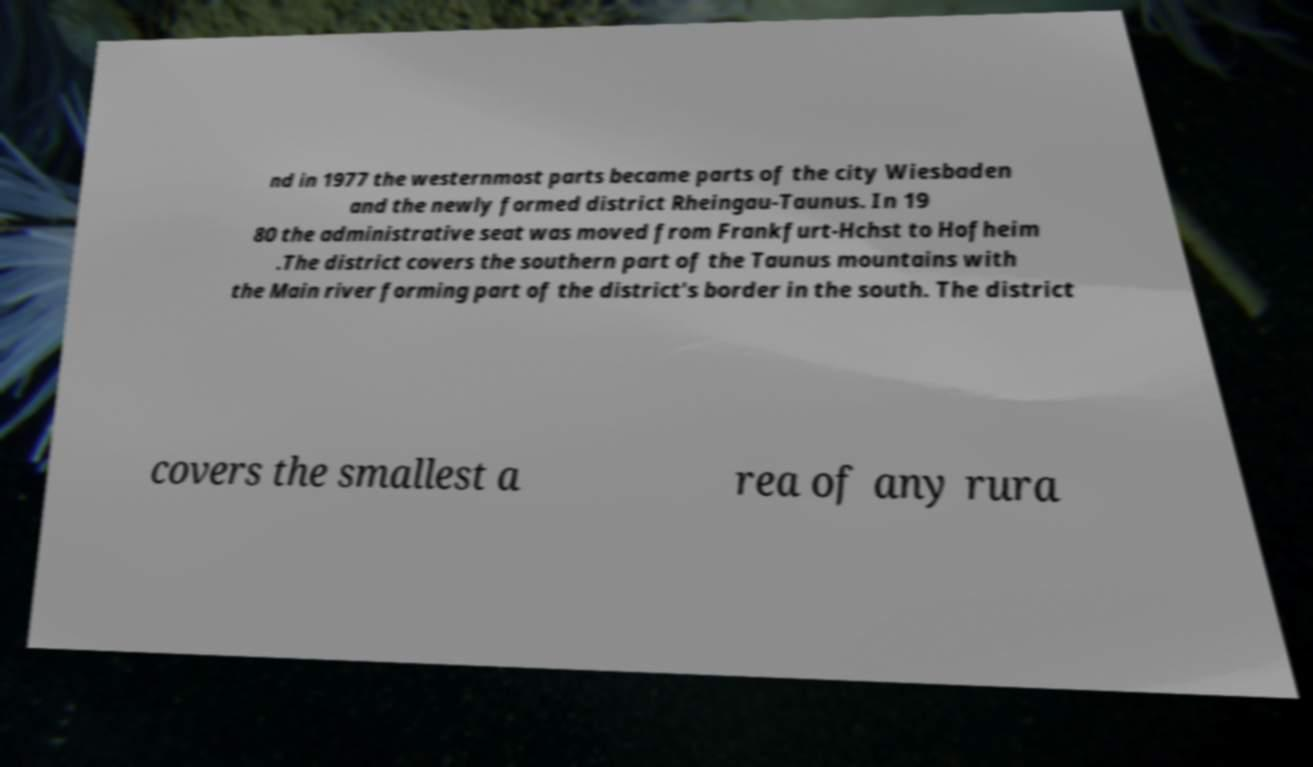Can you accurately transcribe the text from the provided image for me? nd in 1977 the westernmost parts became parts of the city Wiesbaden and the newly formed district Rheingau-Taunus. In 19 80 the administrative seat was moved from Frankfurt-Hchst to Hofheim .The district covers the southern part of the Taunus mountains with the Main river forming part of the district's border in the south. The district covers the smallest a rea of any rura 